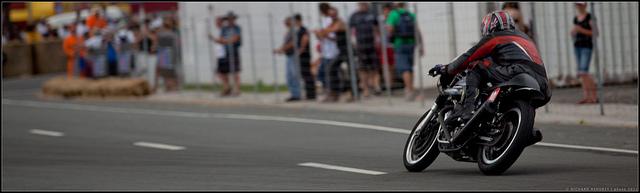Is the man riding down a regular street?
Keep it brief. Yes. Are people standing on the sidewalk or in the road?
Keep it brief. Sidewalk. What is the bicycle leaning on?
Give a very brief answer. Road. What is this?
Be succinct. Motorcycle. Will the man crash on his bike?
Give a very brief answer. No. How many bike tires are in the photo?
Quick response, please. 2. 